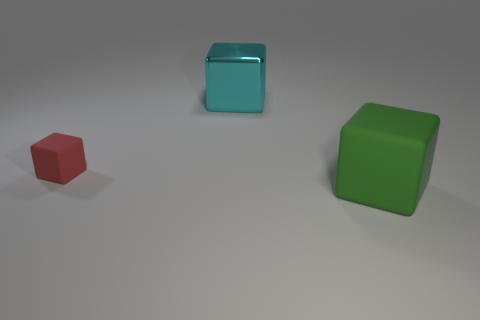Do the large object behind the red object and the large object that is in front of the small red rubber object have the same material?
Your answer should be compact. No. There is a green object; is its size the same as the cube that is on the left side of the cyan shiny object?
Offer a very short reply. No. There is a matte cube left of the cube in front of the small red matte cube; what number of cyan cubes are behind it?
Your answer should be compact. 1. There is a small thing; how many rubber things are in front of it?
Ensure brevity in your answer.  1. There is a thing right of the large object that is behind the green rubber cube; what is its color?
Ensure brevity in your answer.  Green. How many other things are there of the same material as the large cyan thing?
Provide a succinct answer. 0. Are there the same number of green blocks that are to the right of the big cyan metallic object and small purple objects?
Provide a succinct answer. No. What material is the big cube that is behind the small red object left of the large block that is in front of the small red block?
Keep it short and to the point. Metal. What color is the big thing that is left of the green block?
Give a very brief answer. Cyan. There is a rubber object on the left side of the big thing in front of the tiny red cube; what size is it?
Offer a terse response. Small. 